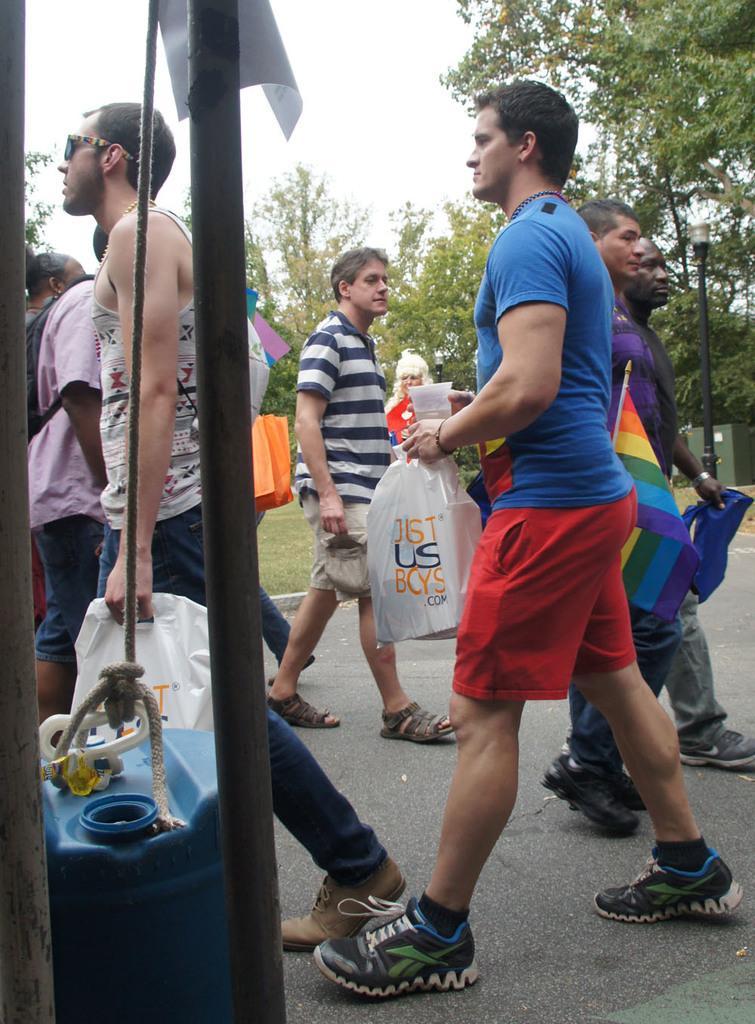Can you describe this image briefly? In this image, we can see a group of people are on the road. Few people are holding some objects. On the left side of the image, we can see poles and barrel tied with rope. In the background, we can see grass, trees, box and sky. 